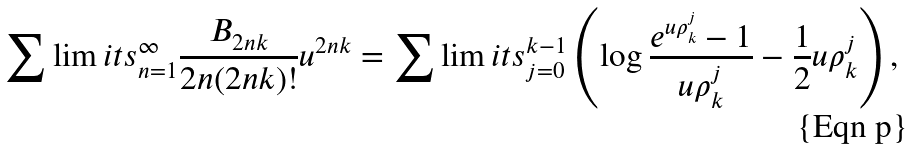Convert formula to latex. <formula><loc_0><loc_0><loc_500><loc_500>\sum \lim i t s _ { n = 1 } ^ { \infty } \frac { B _ { 2 n k } } { 2 n ( 2 n k ) ! } u ^ { 2 n k } = \sum \lim i t s _ { j = 0 } ^ { k - 1 } \left ( \log \frac { e ^ { u \rho _ { k } ^ { j } } - 1 } { u \rho _ { k } ^ { j } } - \frac { 1 } { 2 } u \rho _ { k } ^ { j } \right ) ,</formula> 